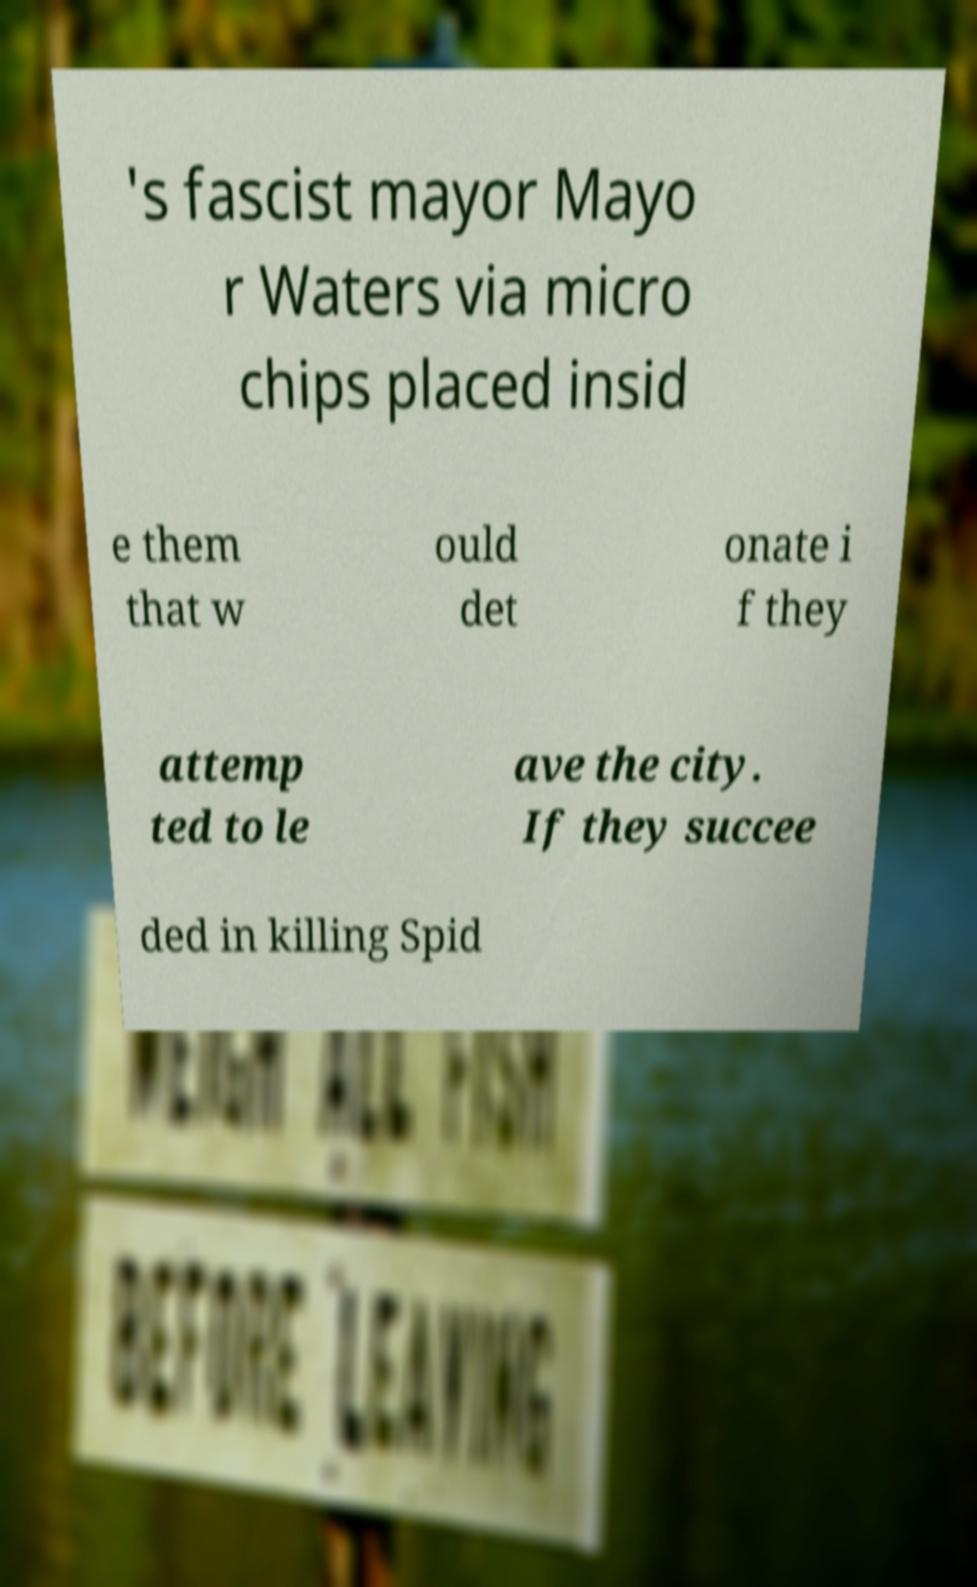What messages or text are displayed in this image? I need them in a readable, typed format. 's fascist mayor Mayo r Waters via micro chips placed insid e them that w ould det onate i f they attemp ted to le ave the city. If they succee ded in killing Spid 